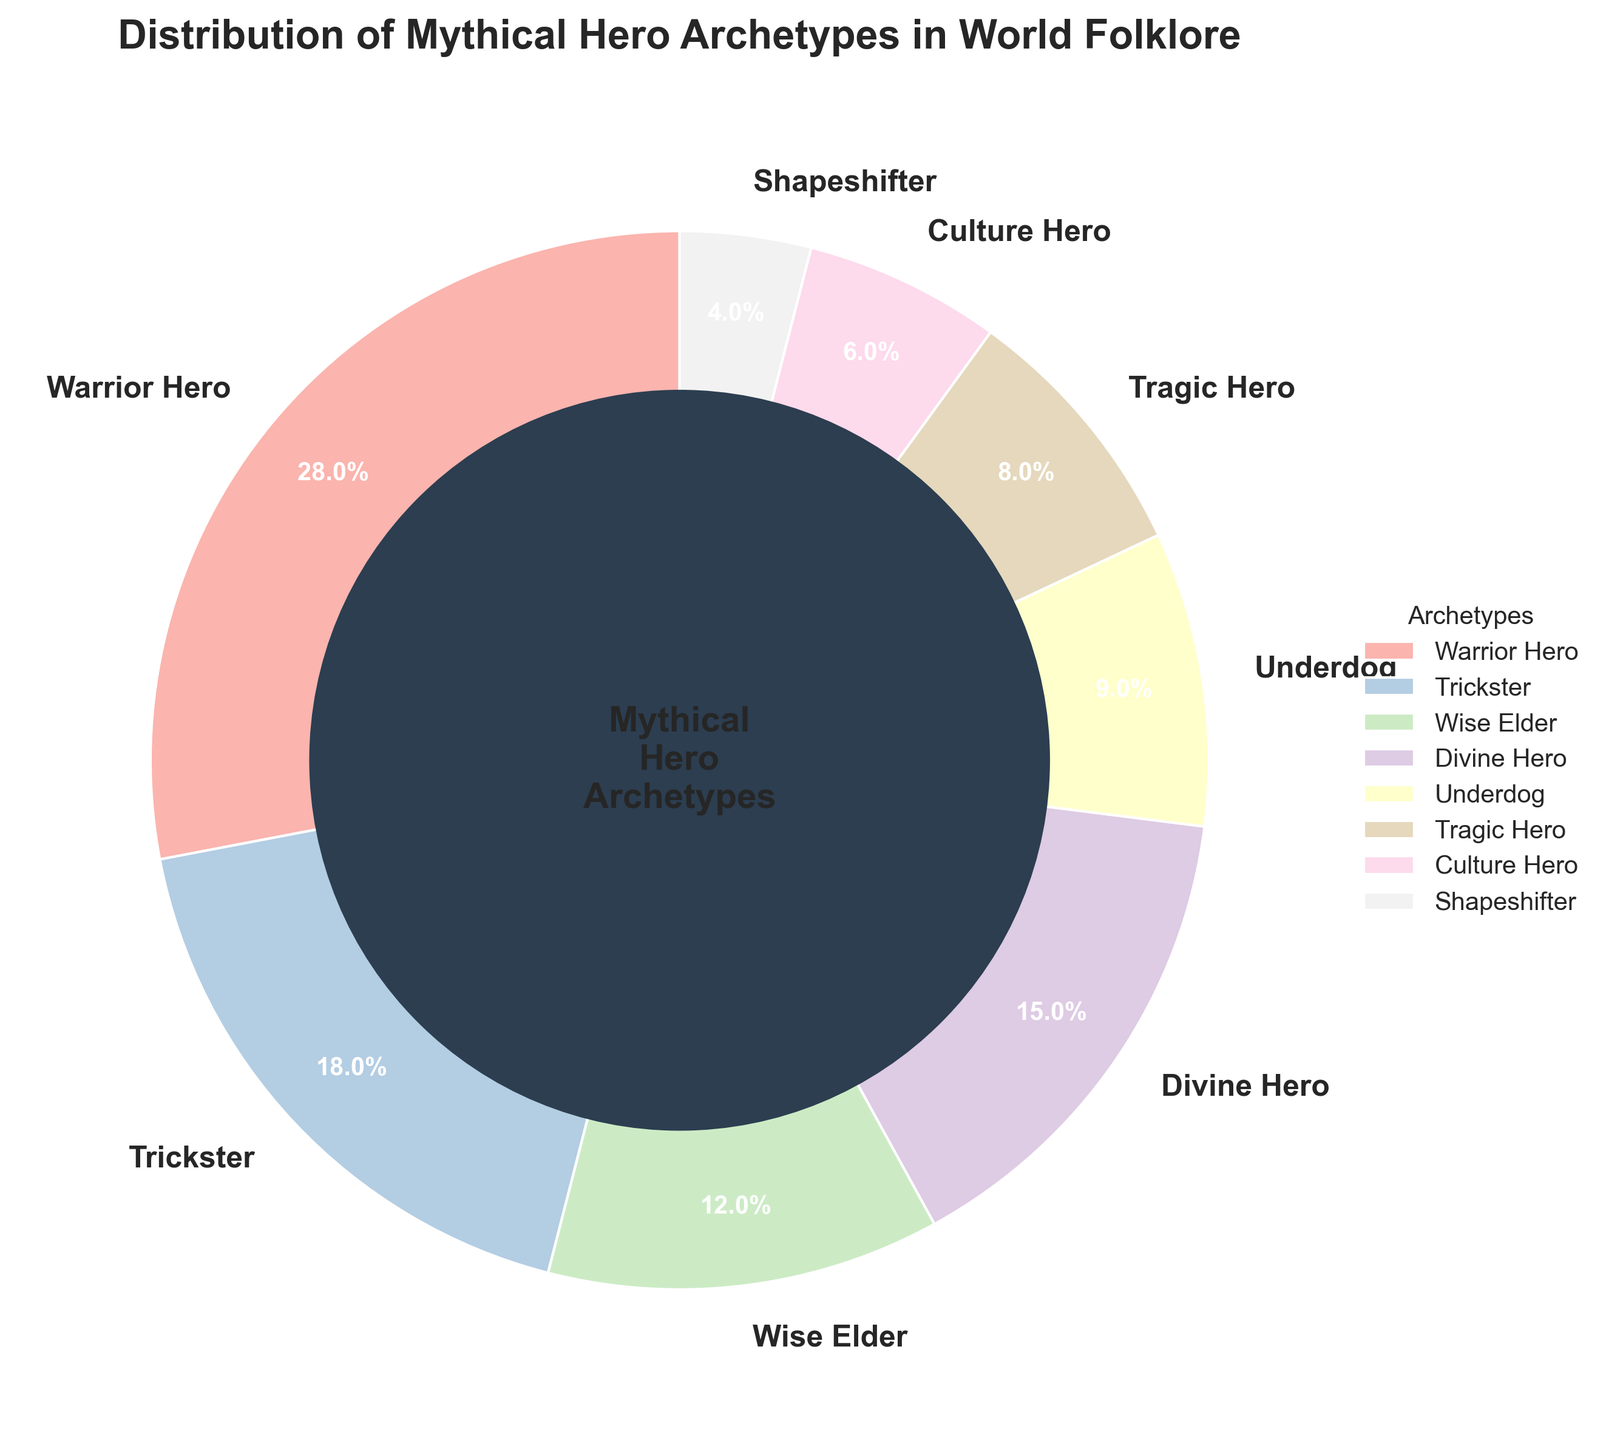What's the most common hero archetype shown in the pie chart? The largest segment in the pie chart represents the "Warrior Hero," which accounts for 28% of the hero archetypes.
Answer: Warrior Hero Which archetype has a larger percentage, Trickster or Wise Elder? From the pie chart, "Trickster" accounts for 18% while "Wise Elder" accounts for 12%. Therefore, Trickster has a larger percentage.
Answer: Trickster How much more prevalent are Warrior Heroes compared to Underdogs in world folklore? The Warrior Hero segment represents 28% and the Underdog segment represents 9%. The difference is 28% - 9%, which is 19%.
Answer: 19% What is the combined percentage of Divine Hero and Tragic Hero archetypes? The pie chart shows Divine Hero at 15% and Tragic Hero at 8%. Adding these together gives 15% + 8%, which is 23%.
Answer: 23% Which archetypes together make up fewer than 10% of the overall distribution? Both Shapeshifter and Culture Hero segments are less than 10%, specifically 4% and 6%, respectively.
Answer: Shapeshifter, Culture Hero Is the percentage of the Trickster archetype greater than the sum of the Culture Hero and Shapeshifter archetypes? Trickster is at 18%, while the sum of Culture Hero (6%) and Shapeshifter (4%) is 6% + 4% = 10%. Therefore, Trickster has a greater percentage.
Answer: Yes What is the total percentage of non-Warrior Hero archetypes? To find this, subtract the percentage of Warrior Hero (28%) from 100%. 100% - 28% = 72%.
Answer: 72% Compare the representation of Divine Heroes to that of Wise Elders. Which is higher, and by how much? Divine Hero represents 15% and Wise Elder represents 12%. The difference is 15% - 12%, which is 3%. Divine Hero is higher.
Answer: 3% Which archetype's representation is closest to 10%? The Underdog archetype is at 9%, which is closest to 10%.
Answer: Underdog Based on the pie chart, list the archetypes in decreasing order of their percentage. The pie chart shows the archetypes in the following order: 1) Warrior Hero (28%) 2) Trickster (18%) 3) Divine Hero (15%) 4) Wise Elder (12%) 5) Underdog (9%) 6) Tragic Hero (8%) 7) Culture Hero (6%) 8) Shapeshifter (4%).
Answer: Warrior Hero, Trickster, Divine Hero, Wise Elder, Underdog, Tragic Hero, Culture Hero, Shapeshifter 